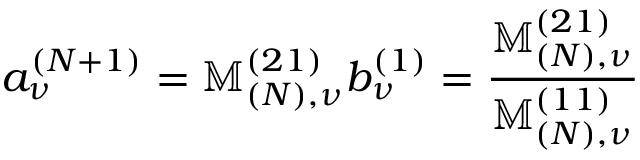<formula> <loc_0><loc_0><loc_500><loc_500>a _ { \nu } ^ { ( N + 1 ) } = \mathbb { M } _ { ( N ) , \nu } ^ { ( 2 1 ) } b _ { \nu } ^ { ( 1 ) } = \frac { \mathbb { M } _ { ( N ) , \nu } ^ { ( 2 1 ) } } { \mathbb { M } _ { ( N ) , \nu } ^ { ( 1 1 ) } }</formula> 